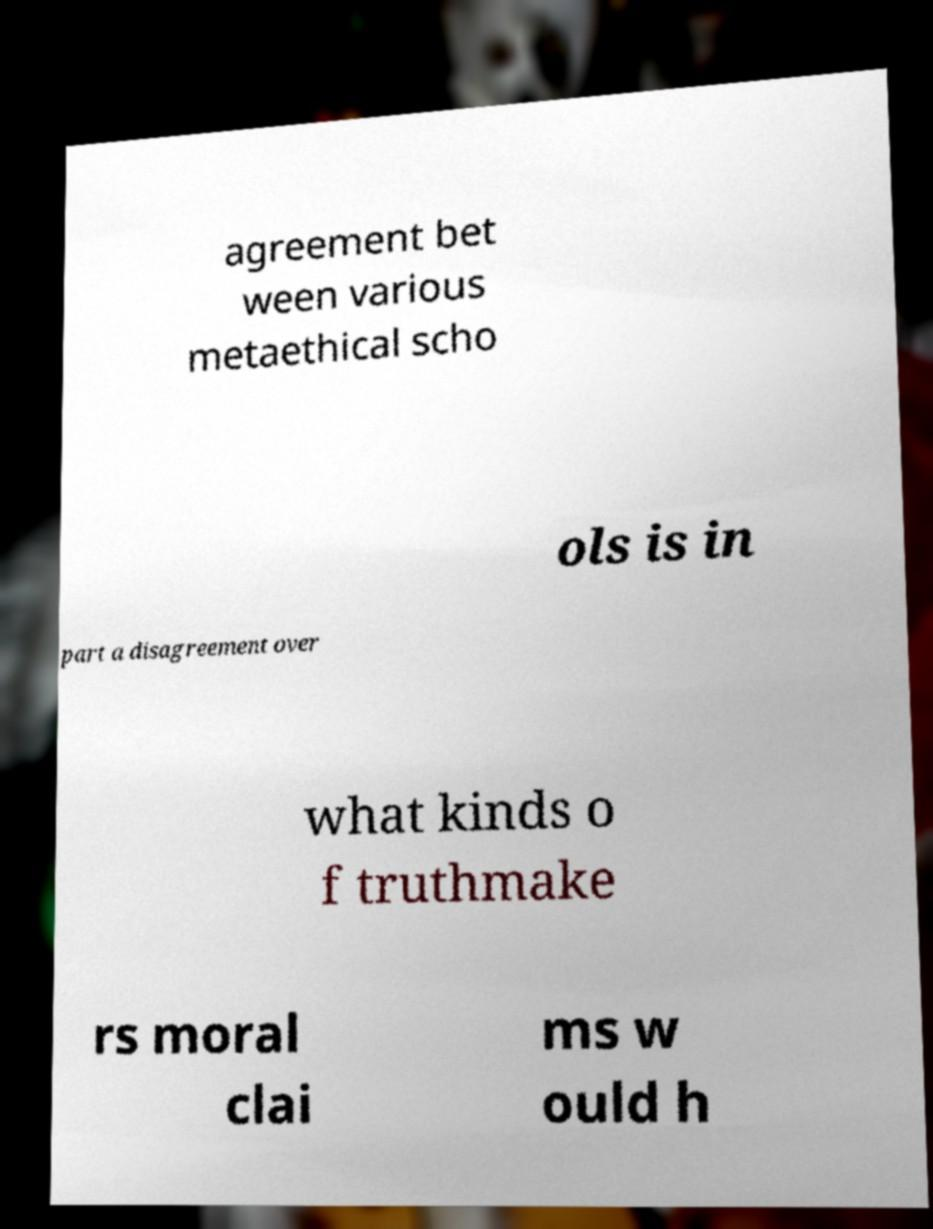For documentation purposes, I need the text within this image transcribed. Could you provide that? agreement bet ween various metaethical scho ols is in part a disagreement over what kinds o f truthmake rs moral clai ms w ould h 